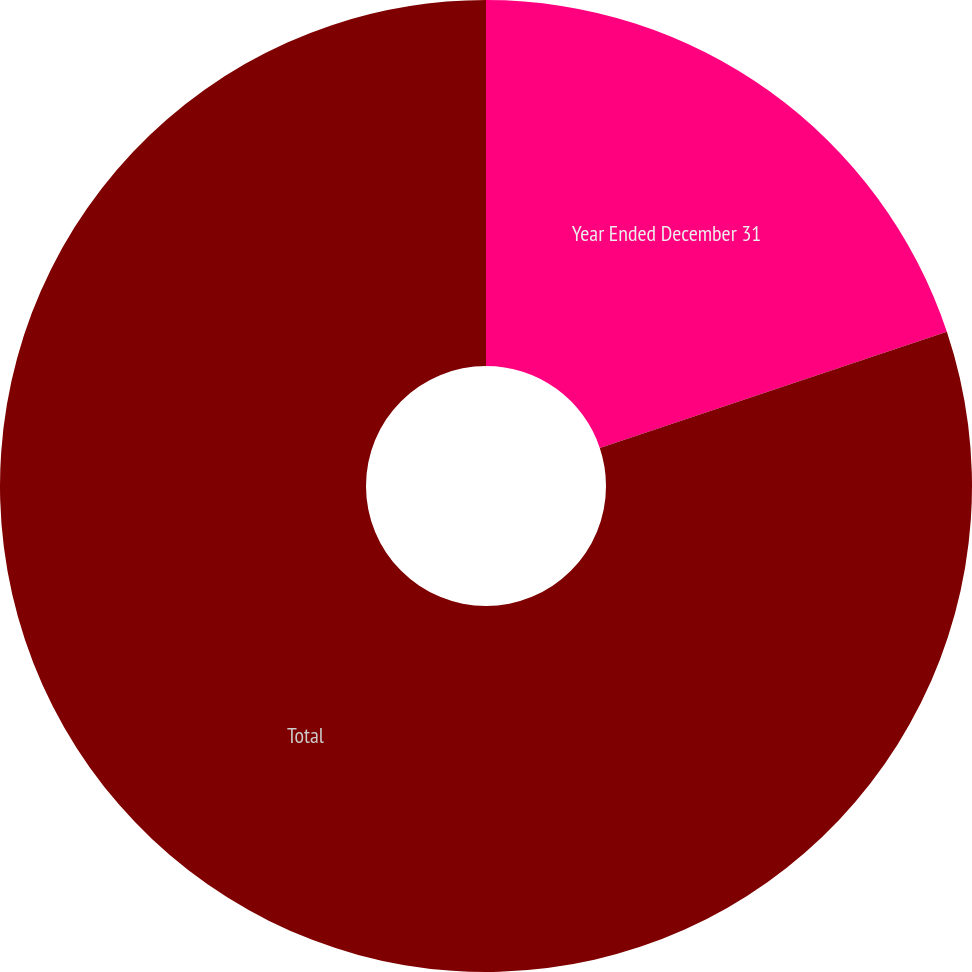Convert chart. <chart><loc_0><loc_0><loc_500><loc_500><pie_chart><fcel>Year Ended December 31<fcel>Total<nl><fcel>19.86%<fcel>80.14%<nl></chart> 